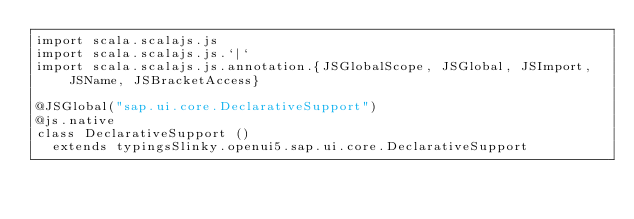<code> <loc_0><loc_0><loc_500><loc_500><_Scala_>import scala.scalajs.js
import scala.scalajs.js.`|`
import scala.scalajs.js.annotation.{JSGlobalScope, JSGlobal, JSImport, JSName, JSBracketAccess}

@JSGlobal("sap.ui.core.DeclarativeSupport")
@js.native
class DeclarativeSupport ()
  extends typingsSlinky.openui5.sap.ui.core.DeclarativeSupport
</code> 